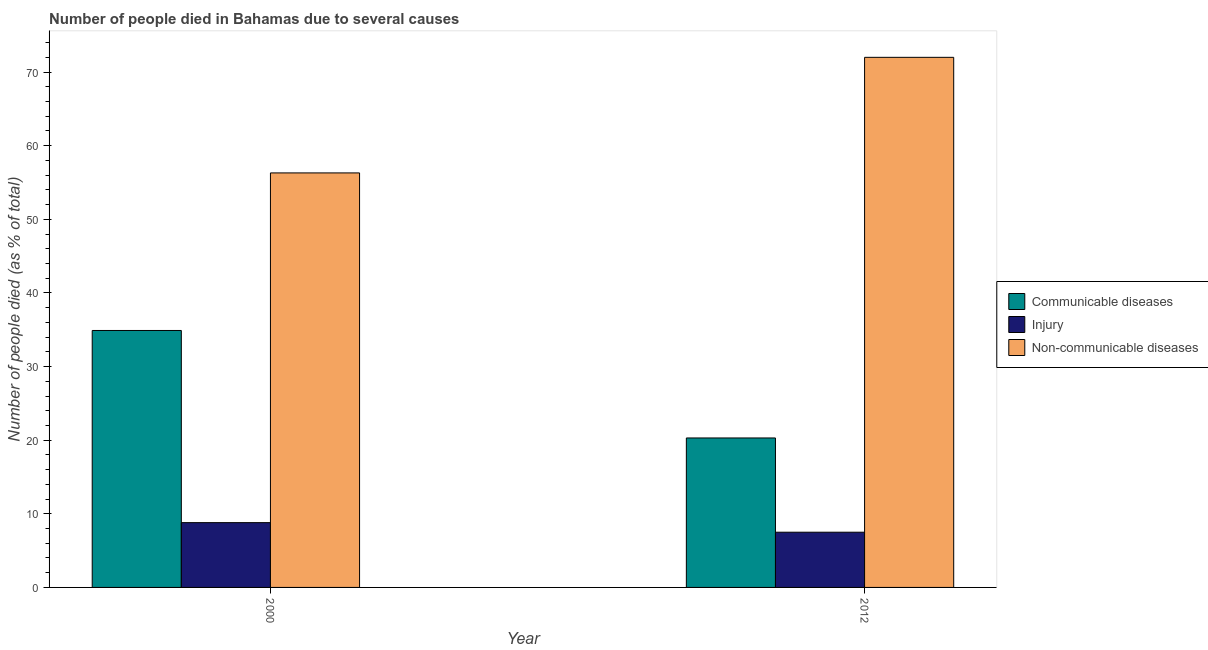Are the number of bars per tick equal to the number of legend labels?
Your answer should be very brief. Yes. How many bars are there on the 2nd tick from the left?
Provide a short and direct response. 3. What is the label of the 2nd group of bars from the left?
Provide a succinct answer. 2012. In how many cases, is the number of bars for a given year not equal to the number of legend labels?
Ensure brevity in your answer.  0. What is the number of people who died of communicable diseases in 2000?
Ensure brevity in your answer.  34.9. Across all years, what is the maximum number of people who dies of non-communicable diseases?
Provide a short and direct response. 72. Across all years, what is the minimum number of people who died of injury?
Provide a succinct answer. 7.5. In which year was the number of people who died of communicable diseases maximum?
Ensure brevity in your answer.  2000. What is the total number of people who died of communicable diseases in the graph?
Provide a short and direct response. 55.2. What is the difference between the number of people who dies of non-communicable diseases in 2000 and that in 2012?
Your answer should be compact. -15.7. What is the difference between the number of people who died of injury in 2000 and the number of people who died of communicable diseases in 2012?
Ensure brevity in your answer.  1.3. What is the average number of people who dies of non-communicable diseases per year?
Provide a succinct answer. 64.15. In the year 2000, what is the difference between the number of people who died of injury and number of people who died of communicable diseases?
Offer a very short reply. 0. In how many years, is the number of people who dies of non-communicable diseases greater than 20 %?
Provide a succinct answer. 2. What is the ratio of the number of people who died of injury in 2000 to that in 2012?
Offer a very short reply. 1.17. In how many years, is the number of people who died of injury greater than the average number of people who died of injury taken over all years?
Your answer should be compact. 1. What does the 1st bar from the left in 2000 represents?
Your response must be concise. Communicable diseases. What does the 2nd bar from the right in 2000 represents?
Your answer should be very brief. Injury. Are the values on the major ticks of Y-axis written in scientific E-notation?
Your answer should be very brief. No. Does the graph contain grids?
Your answer should be very brief. No. How many legend labels are there?
Your answer should be very brief. 3. What is the title of the graph?
Provide a short and direct response. Number of people died in Bahamas due to several causes. Does "Female employers" appear as one of the legend labels in the graph?
Make the answer very short. No. What is the label or title of the Y-axis?
Your answer should be compact. Number of people died (as % of total). What is the Number of people died (as % of total) in Communicable diseases in 2000?
Offer a very short reply. 34.9. What is the Number of people died (as % of total) in Non-communicable diseases in 2000?
Your response must be concise. 56.3. What is the Number of people died (as % of total) of Communicable diseases in 2012?
Keep it short and to the point. 20.3. What is the Number of people died (as % of total) in Non-communicable diseases in 2012?
Provide a succinct answer. 72. Across all years, what is the maximum Number of people died (as % of total) of Communicable diseases?
Provide a short and direct response. 34.9. Across all years, what is the maximum Number of people died (as % of total) of Injury?
Offer a very short reply. 8.8. Across all years, what is the minimum Number of people died (as % of total) in Communicable diseases?
Keep it short and to the point. 20.3. Across all years, what is the minimum Number of people died (as % of total) in Non-communicable diseases?
Provide a succinct answer. 56.3. What is the total Number of people died (as % of total) in Communicable diseases in the graph?
Your answer should be very brief. 55.2. What is the total Number of people died (as % of total) in Injury in the graph?
Make the answer very short. 16.3. What is the total Number of people died (as % of total) of Non-communicable diseases in the graph?
Give a very brief answer. 128.3. What is the difference between the Number of people died (as % of total) in Communicable diseases in 2000 and that in 2012?
Offer a very short reply. 14.6. What is the difference between the Number of people died (as % of total) of Injury in 2000 and that in 2012?
Ensure brevity in your answer.  1.3. What is the difference between the Number of people died (as % of total) of Non-communicable diseases in 2000 and that in 2012?
Make the answer very short. -15.7. What is the difference between the Number of people died (as % of total) of Communicable diseases in 2000 and the Number of people died (as % of total) of Injury in 2012?
Make the answer very short. 27.4. What is the difference between the Number of people died (as % of total) of Communicable diseases in 2000 and the Number of people died (as % of total) of Non-communicable diseases in 2012?
Offer a terse response. -37.1. What is the difference between the Number of people died (as % of total) of Injury in 2000 and the Number of people died (as % of total) of Non-communicable diseases in 2012?
Ensure brevity in your answer.  -63.2. What is the average Number of people died (as % of total) in Communicable diseases per year?
Offer a very short reply. 27.6. What is the average Number of people died (as % of total) of Injury per year?
Your answer should be very brief. 8.15. What is the average Number of people died (as % of total) in Non-communicable diseases per year?
Your answer should be very brief. 64.15. In the year 2000, what is the difference between the Number of people died (as % of total) of Communicable diseases and Number of people died (as % of total) of Injury?
Give a very brief answer. 26.1. In the year 2000, what is the difference between the Number of people died (as % of total) of Communicable diseases and Number of people died (as % of total) of Non-communicable diseases?
Offer a terse response. -21.4. In the year 2000, what is the difference between the Number of people died (as % of total) of Injury and Number of people died (as % of total) of Non-communicable diseases?
Offer a very short reply. -47.5. In the year 2012, what is the difference between the Number of people died (as % of total) of Communicable diseases and Number of people died (as % of total) of Injury?
Provide a short and direct response. 12.8. In the year 2012, what is the difference between the Number of people died (as % of total) in Communicable diseases and Number of people died (as % of total) in Non-communicable diseases?
Ensure brevity in your answer.  -51.7. In the year 2012, what is the difference between the Number of people died (as % of total) of Injury and Number of people died (as % of total) of Non-communicable diseases?
Your answer should be compact. -64.5. What is the ratio of the Number of people died (as % of total) in Communicable diseases in 2000 to that in 2012?
Provide a short and direct response. 1.72. What is the ratio of the Number of people died (as % of total) in Injury in 2000 to that in 2012?
Offer a very short reply. 1.17. What is the ratio of the Number of people died (as % of total) in Non-communicable diseases in 2000 to that in 2012?
Keep it short and to the point. 0.78. What is the difference between the highest and the second highest Number of people died (as % of total) of Injury?
Keep it short and to the point. 1.3. What is the difference between the highest and the lowest Number of people died (as % of total) in Injury?
Provide a short and direct response. 1.3. 